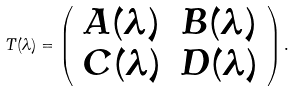<formula> <loc_0><loc_0><loc_500><loc_500>T ( \lambda ) = \left ( \begin{array} { c c } A ( \lambda ) & B ( \lambda ) \\ C ( \lambda ) & D ( \lambda ) \end{array} \right ) .</formula> 